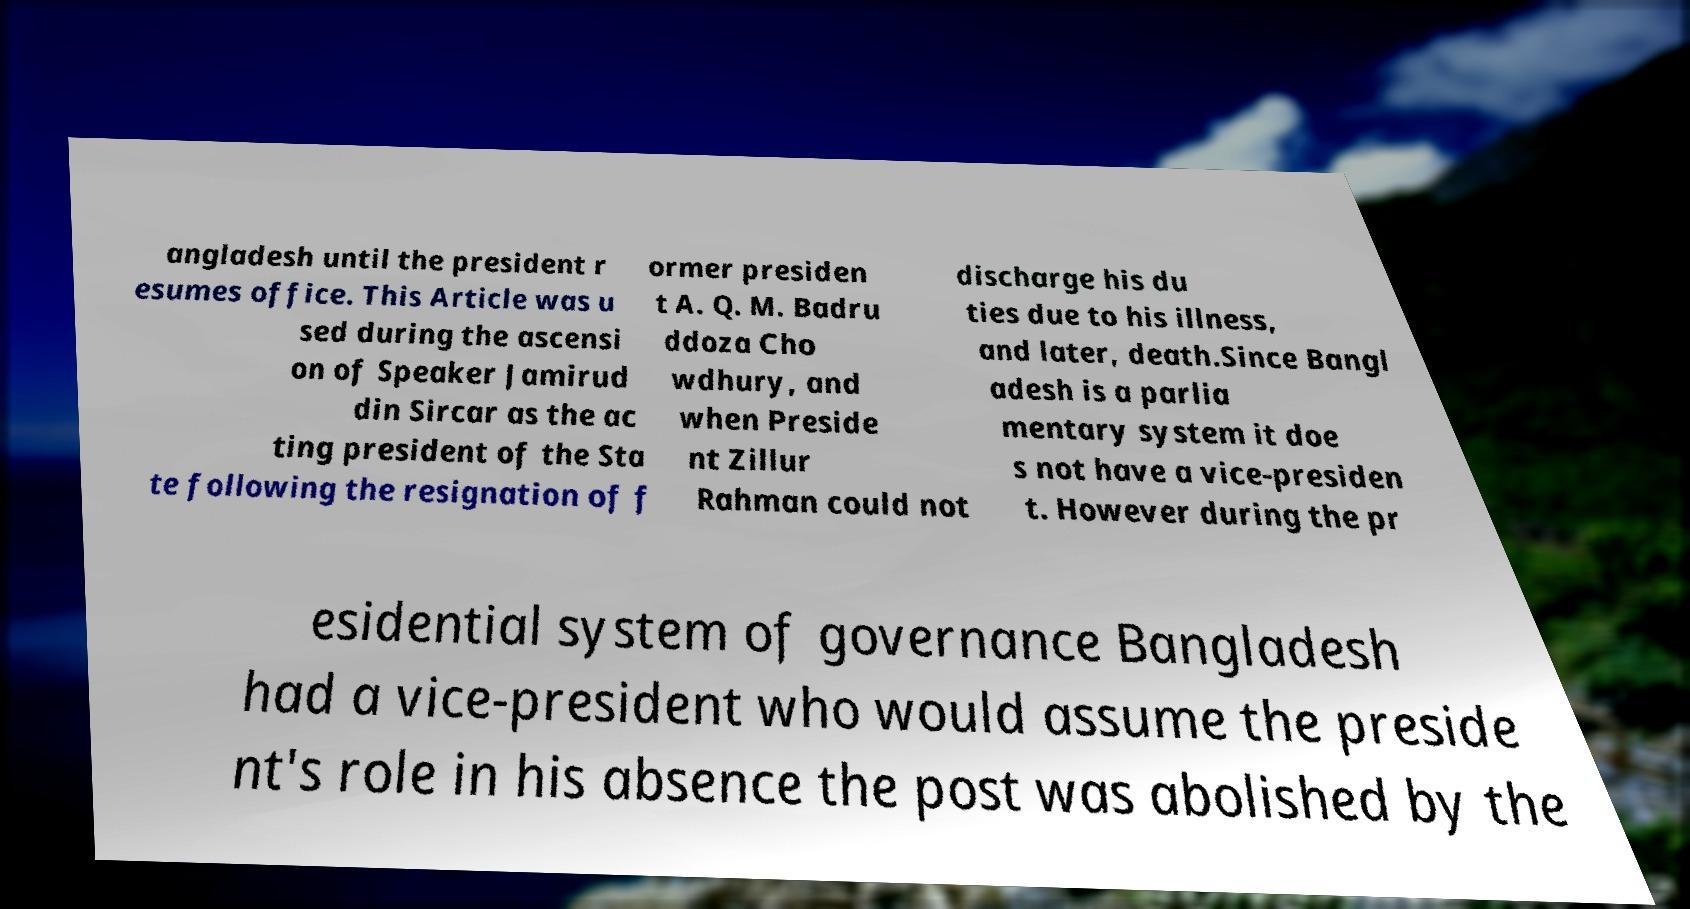I need the written content from this picture converted into text. Can you do that? angladesh until the president r esumes office. This Article was u sed during the ascensi on of Speaker Jamirud din Sircar as the ac ting president of the Sta te following the resignation of f ormer presiden t A. Q. M. Badru ddoza Cho wdhury, and when Preside nt Zillur Rahman could not discharge his du ties due to his illness, and later, death.Since Bangl adesh is a parlia mentary system it doe s not have a vice-presiden t. However during the pr esidential system of governance Bangladesh had a vice-president who would assume the preside nt's role in his absence the post was abolished by the 